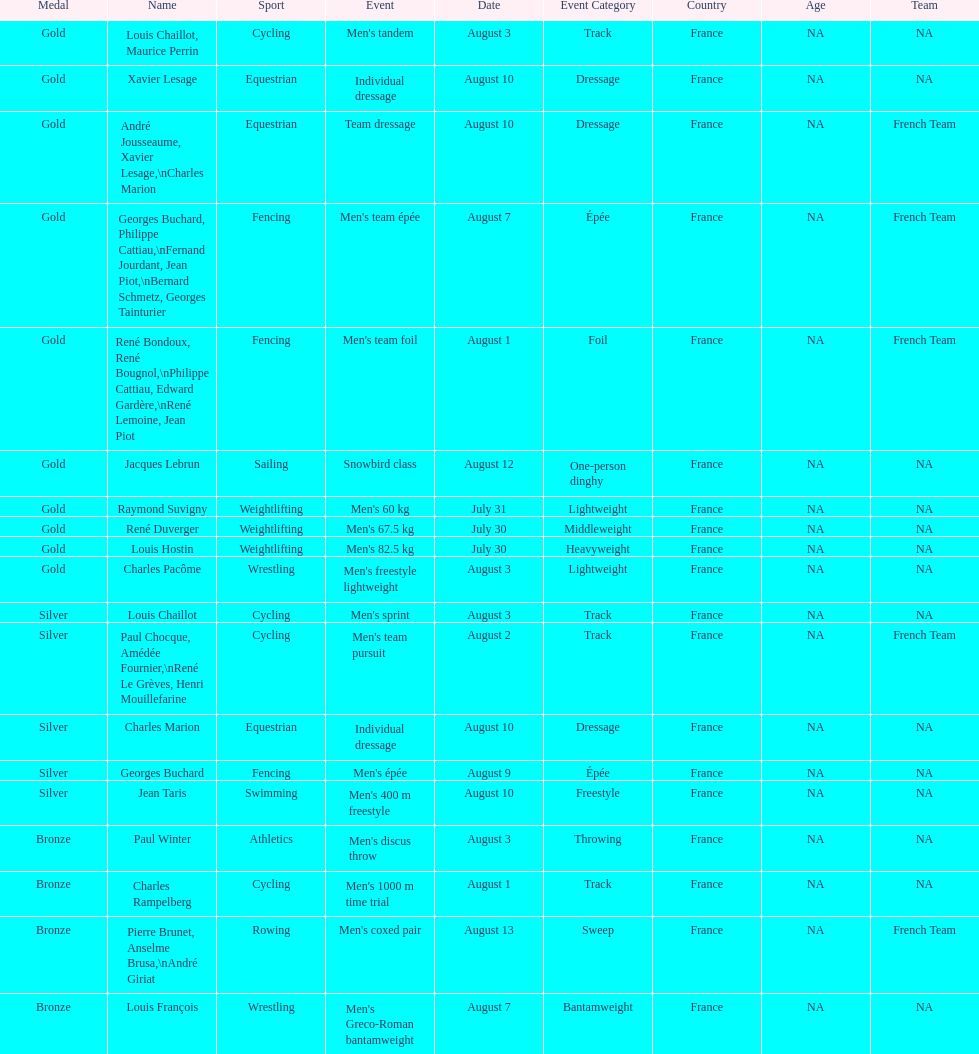Could you parse the entire table? {'header': ['Medal', 'Name', 'Sport', 'Event', 'Date', 'Event Category', 'Country', 'Age', 'Team'], 'rows': [['Gold', 'Louis Chaillot, Maurice Perrin', 'Cycling', "Men's tandem", 'August 3', 'Track', 'France', 'NA', 'NA'], ['Gold', 'Xavier Lesage', 'Equestrian', 'Individual dressage', 'August 10', 'Dressage', 'France', 'NA', 'NA'], ['Gold', 'André Jousseaume, Xavier Lesage,\\nCharles Marion', 'Equestrian', 'Team dressage', 'August 10', 'Dressage', 'France', 'NA', 'French Team'], ['Gold', 'Georges Buchard, Philippe Cattiau,\\nFernand Jourdant, Jean Piot,\\nBernard Schmetz, Georges Tainturier', 'Fencing', "Men's team épée", 'August 7', 'Épée', 'France', 'NA', 'French Team'], ['Gold', 'René Bondoux, René Bougnol,\\nPhilippe Cattiau, Edward Gardère,\\nRené Lemoine, Jean Piot', 'Fencing', "Men's team foil", 'August 1', 'Foil', 'France', 'NA', 'French Team'], ['Gold', 'Jacques Lebrun', 'Sailing', 'Snowbird class', 'August 12', 'One-person dinghy', 'France', 'NA', 'NA'], ['Gold', 'Raymond Suvigny', 'Weightlifting', "Men's 60 kg", 'July 31', 'Lightweight', 'France', 'NA', 'NA'], ['Gold', 'René Duverger', 'Weightlifting', "Men's 67.5 kg", 'July 30', 'Middleweight', 'France', 'NA', 'NA'], ['Gold', 'Louis Hostin', 'Weightlifting', "Men's 82.5 kg", 'July 30', 'Heavyweight', 'France', 'NA', 'NA'], ['Gold', 'Charles Pacôme', 'Wrestling', "Men's freestyle lightweight", 'August 3', 'Lightweight', 'France', 'NA', 'NA'], ['Silver', 'Louis Chaillot', 'Cycling', "Men's sprint", 'August 3', 'Track', 'France', 'NA', 'NA'], ['Silver', 'Paul Chocque, Amédée Fournier,\\nRené Le Grèves, Henri Mouillefarine', 'Cycling', "Men's team pursuit", 'August 2', 'Track', 'France', 'NA', 'French Team'], ['Silver', 'Charles Marion', 'Equestrian', 'Individual dressage', 'August 10', 'Dressage', 'France', 'NA', 'NA'], ['Silver', 'Georges Buchard', 'Fencing', "Men's épée", 'August 9', 'Épée', 'France', 'NA', 'NA'], ['Silver', 'Jean Taris', 'Swimming', "Men's 400 m freestyle", 'August 10', 'Freestyle', 'France', 'NA', 'NA'], ['Bronze', 'Paul Winter', 'Athletics', "Men's discus throw", 'August 3', 'Throwing', 'France', 'NA', 'NA'], ['Bronze', 'Charles Rampelberg', 'Cycling', "Men's 1000 m time trial", 'August 1', 'Track', 'France', 'NA', 'NA'], ['Bronze', 'Pierre Brunet, Anselme Brusa,\\nAndré Giriat', 'Rowing', "Men's coxed pair", 'August 13', 'Sweep', 'France', 'NA', 'French Team'], ['Bronze', 'Louis François', 'Wrestling', "Men's Greco-Roman bantamweight", 'August 7', 'Bantamweight', 'France', 'NA', 'NA']]} Was there more gold medals won than silver? Yes. 